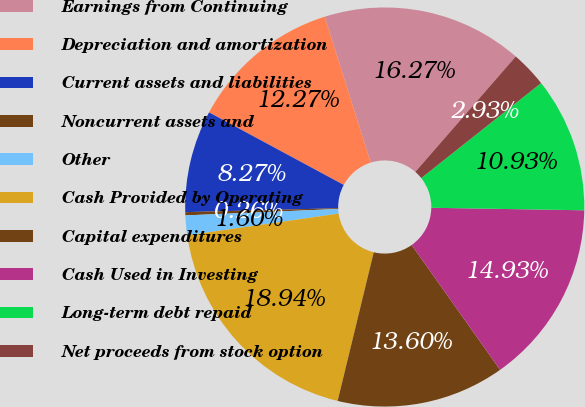<chart> <loc_0><loc_0><loc_500><loc_500><pie_chart><fcel>Earnings from Continuing<fcel>Depreciation and amortization<fcel>Current assets and liabilities<fcel>Noncurrent assets and<fcel>Other<fcel>Cash Provided by Operating<fcel>Capital expenditures<fcel>Cash Used in Investing<fcel>Long-term debt repaid<fcel>Net proceeds from stock option<nl><fcel>16.27%<fcel>12.27%<fcel>8.27%<fcel>0.26%<fcel>1.6%<fcel>18.94%<fcel>13.6%<fcel>14.93%<fcel>10.93%<fcel>2.93%<nl></chart> 